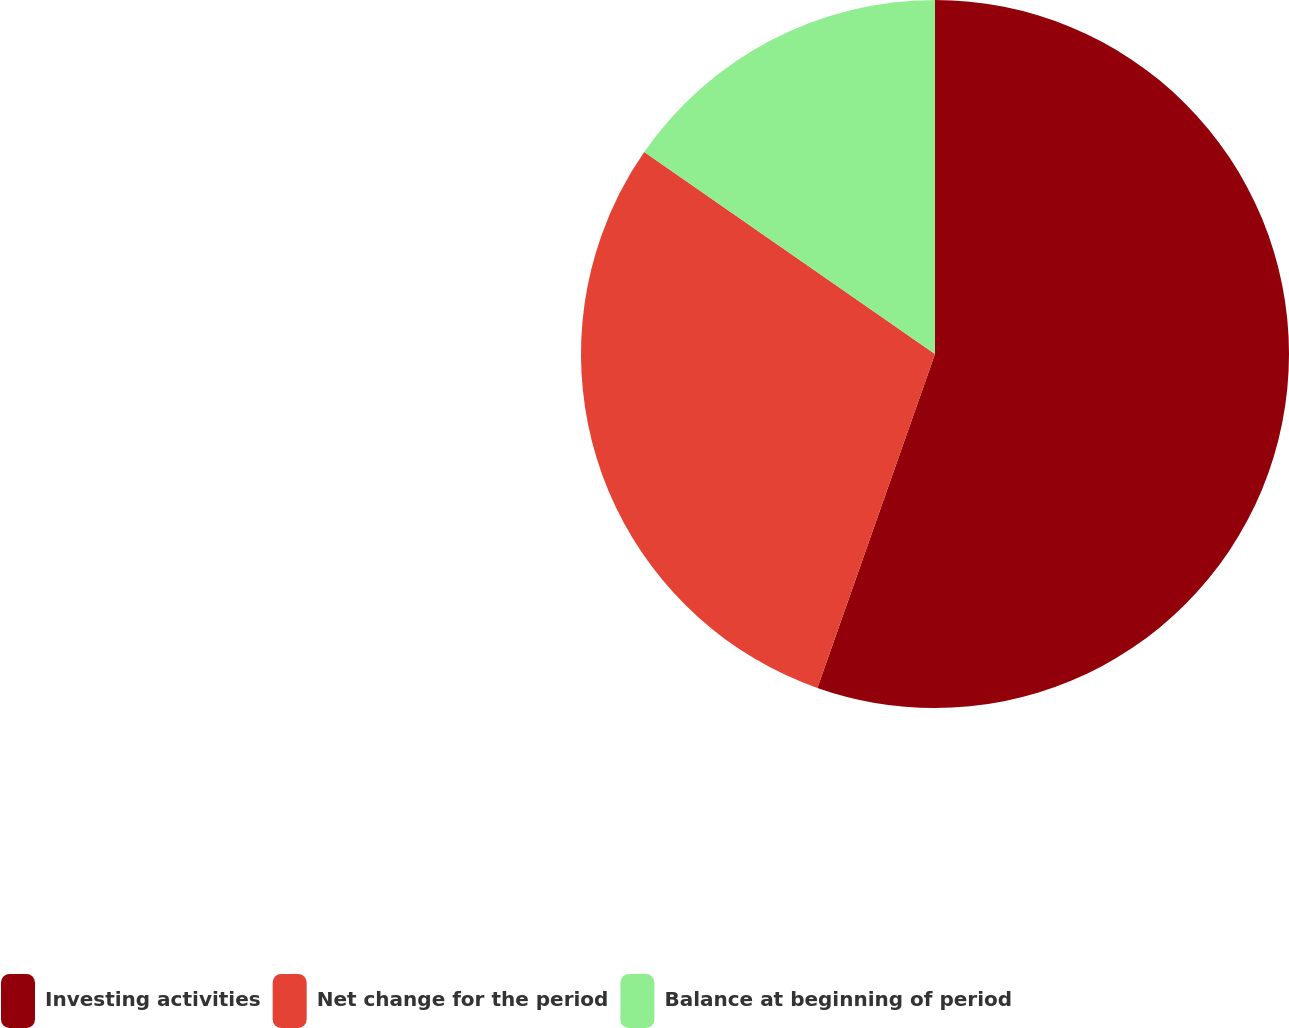<chart> <loc_0><loc_0><loc_500><loc_500><pie_chart><fcel>Investing activities<fcel>Net change for the period<fcel>Balance at beginning of period<nl><fcel>55.39%<fcel>29.27%<fcel>15.34%<nl></chart> 